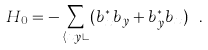Convert formula to latex. <formula><loc_0><loc_0><loc_500><loc_500>H _ { 0 } = - \sum _ { \langle x y \rangle } ( b ^ { * } _ { x } b _ { y } + b ^ { * } _ { y } b _ { x } ) \ .</formula> 